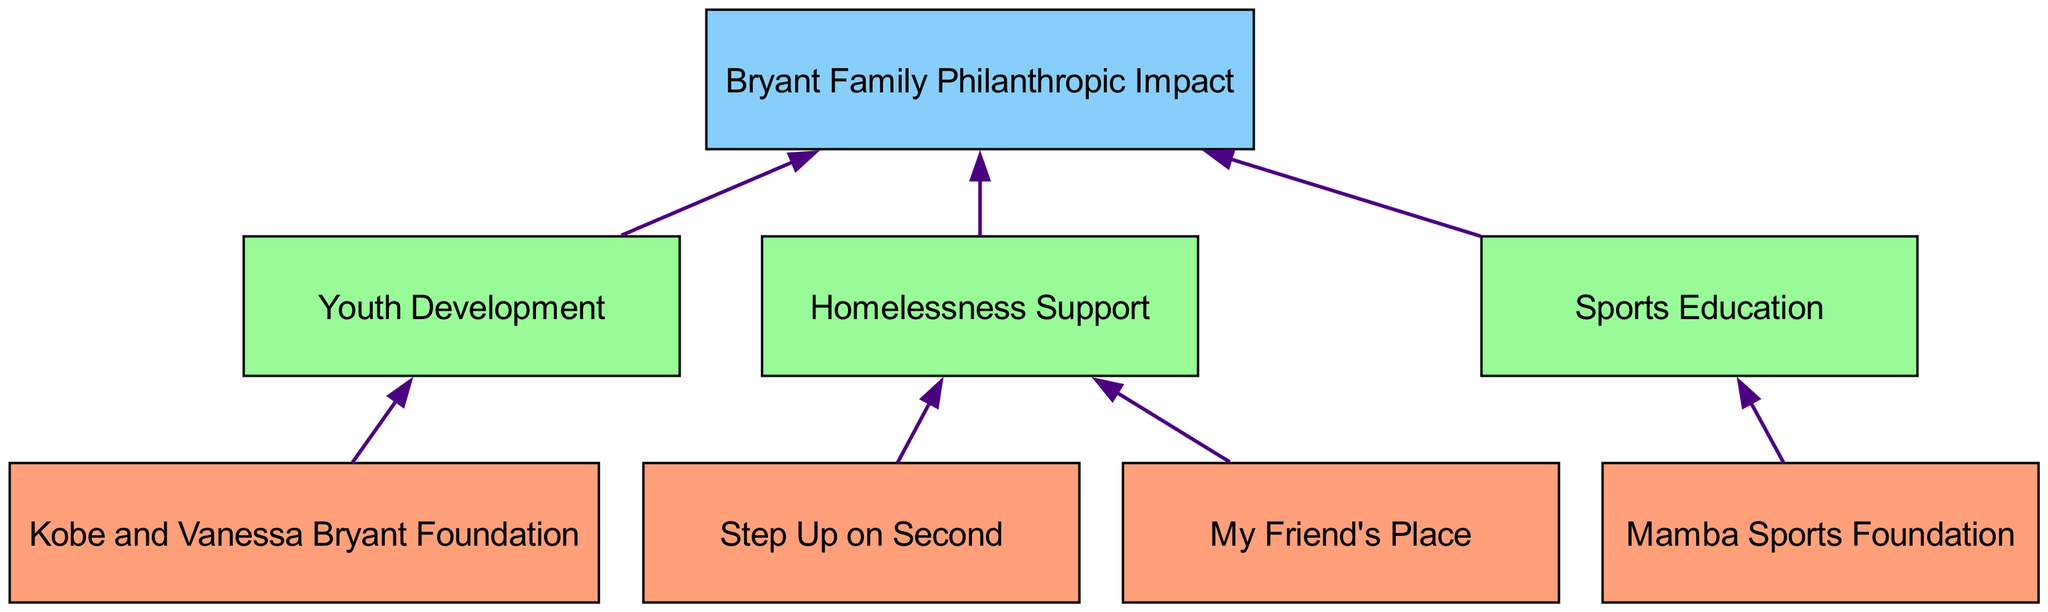What are the bottom-level organizations in the diagram? The bottom-level organizations are listed in the diagram: "Kobe and Vanessa Bryant Foundation", "Mamba Sports Foundation", "Step Up on Second", and "My Friend's Place".
Answer: Kobe and Vanessa Bryant Foundation, Mamba Sports Foundation, Step Up on Second, My Friend's Place How many middle-level categories are present? The diagram shows three middle-level categories: "Youth Development", "Homelessness Support", and "Sports Education". Counting these gives a total of three.
Answer: 3 Which organization is connected to 'Sports Education'? In the diagram, the "Mamba Sports Foundation" is the only organization directly connected to the "Sports Education" category.
Answer: Mamba Sports Foundation What is the relationship between 'Step Up on Second' and 'Bryant Family Philanthropic Impact'? "Step Up on Second" is connected to "Homelessness Support", and since "Homelessness Support" is then connected to "Bryant Family Philanthropic Impact", the organization indirectly contributes to the impact through this connection.
Answer: Indirect Which level contains the most connections to the top level? The middle level contains the most connections to the top level; specifically, it has a total of three connections: "Youth Development", "Homelessness Support", and "Sports Education" all direct to "Bryant Family Philanthropic Impact".
Answer: Middle level How many unique connections are there in the diagram? By examining the connections provided in the diagram, there are a total of seven unique connections listed.
Answer: 7 What is the top-level node in the diagram? The diagram presents the top-level node as "Bryant Family Philanthropic Impact". This node summarizes the overall impact of the philanthropic activities detailed below.
Answer: Bryant Family Philanthropic Impact Which bottom-level organization is linked to the 'Youth Development' category? The "Kobe and Vanessa Bryant Foundation" is the bottom-level organization that is directly linked to the 'Youth Development' category in the diagram.
Answer: Kobe and Vanessa Bryant Foundation 